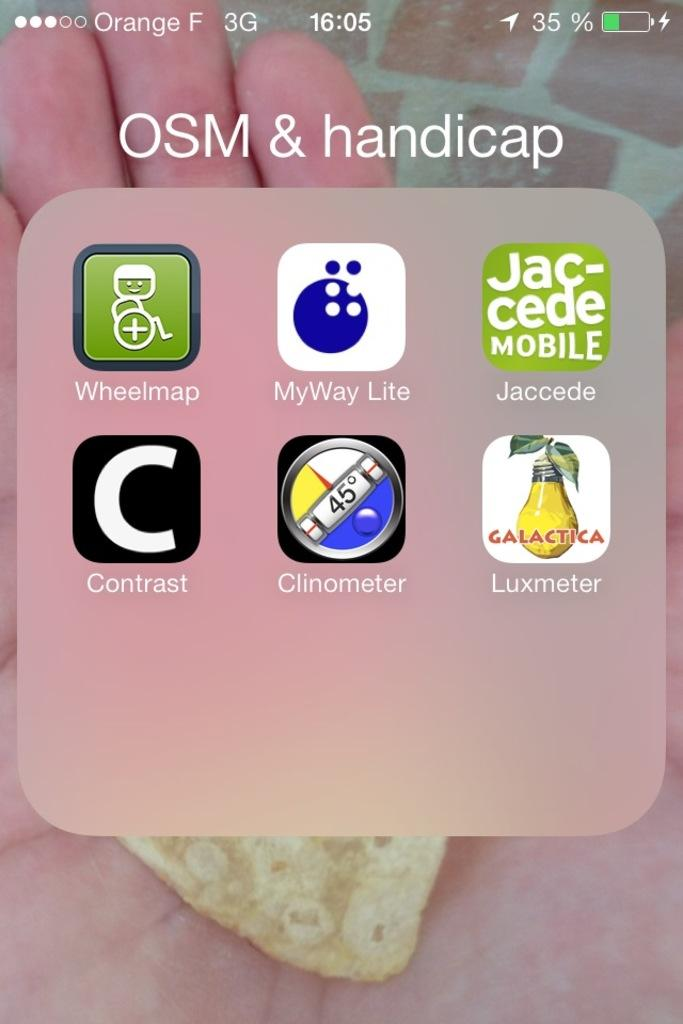<image>
Create a compact narrative representing the image presented. a phone is open to a folder named OSM & handicap 